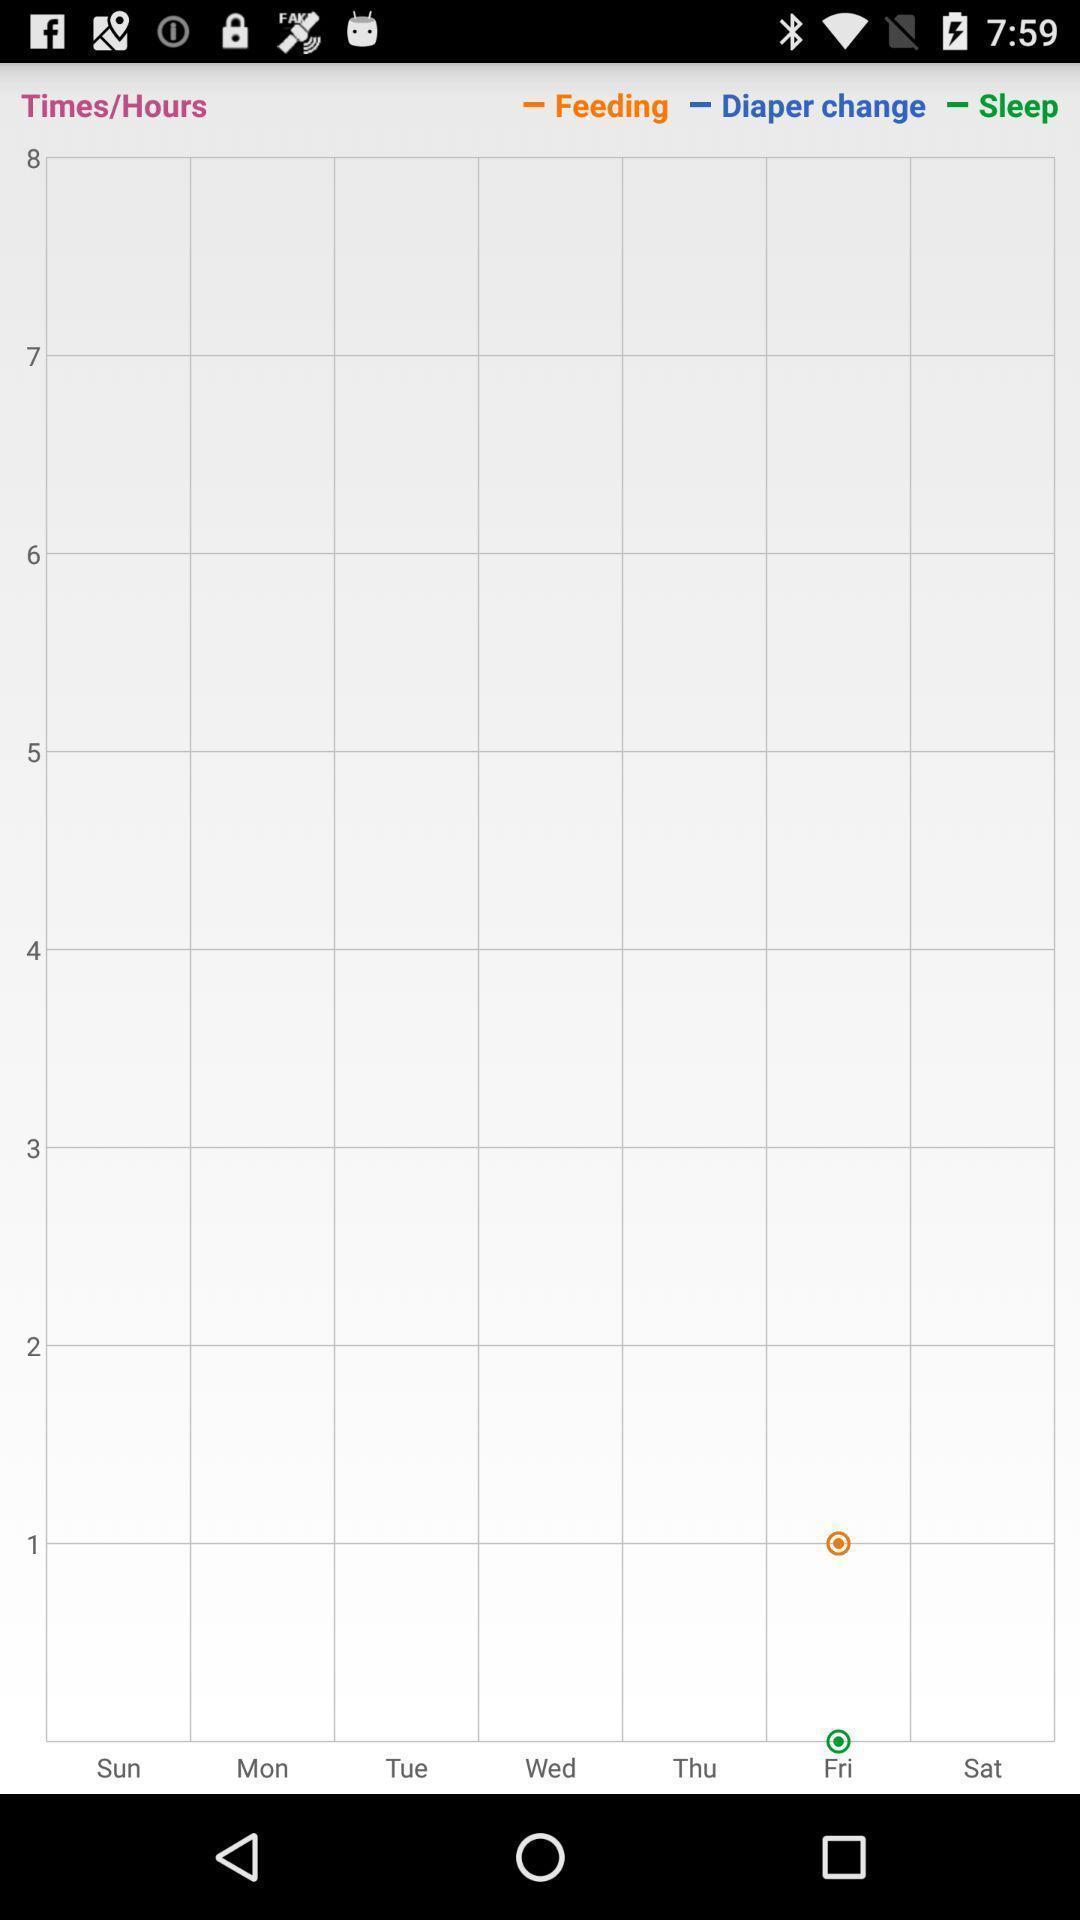Summarize the main components in this picture. Screen showing a graph for a baby care app. 